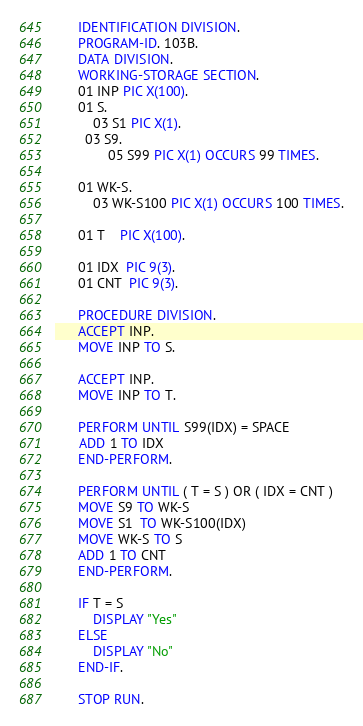Convert code to text. <code><loc_0><loc_0><loc_500><loc_500><_COBOL_>      IDENTIFICATION DIVISION.
      PROGRAM-ID. 103B.
      DATA DIVISION.
      WORKING-STORAGE SECTION.
      01 INP PIC X(100).
      01 S.
      	03 S1 PIC X(1).
        03 S9.
      		05 S99 PIC X(1) OCCURS 99 TIMES.

      01 WK-S.
      	03 WK-S100 PIC X(1) OCCURS 100 TIMES.
      
      01 T    PIC X(100).
      
      01 IDX  PIC 9(3).
      01 CNT  PIC 9(3).
      
      PROCEDURE DIVISION.
      ACCEPT INP.
      MOVE INP TO S.
      
      ACCEPT INP.
      MOVE INP TO T.
      
      PERFORM UNTIL S99(IDX) = SPACE
      ADD 1 TO IDX
      END-PERFORM.
      
      PERFORM UNTIL ( T = S ) OR ( IDX = CNT ) 
      MOVE S9 TO WK-S
      MOVE S1  TO WK-S100(IDX)
      MOVE WK-S TO S
      ADD 1 TO CNT
      END-PERFORM.
      
      IF T = S 
      	DISPLAY "Yes"
      ELSE
      	DISPLAY "No"
      END-IF.
      
      STOP RUN.
</code> 